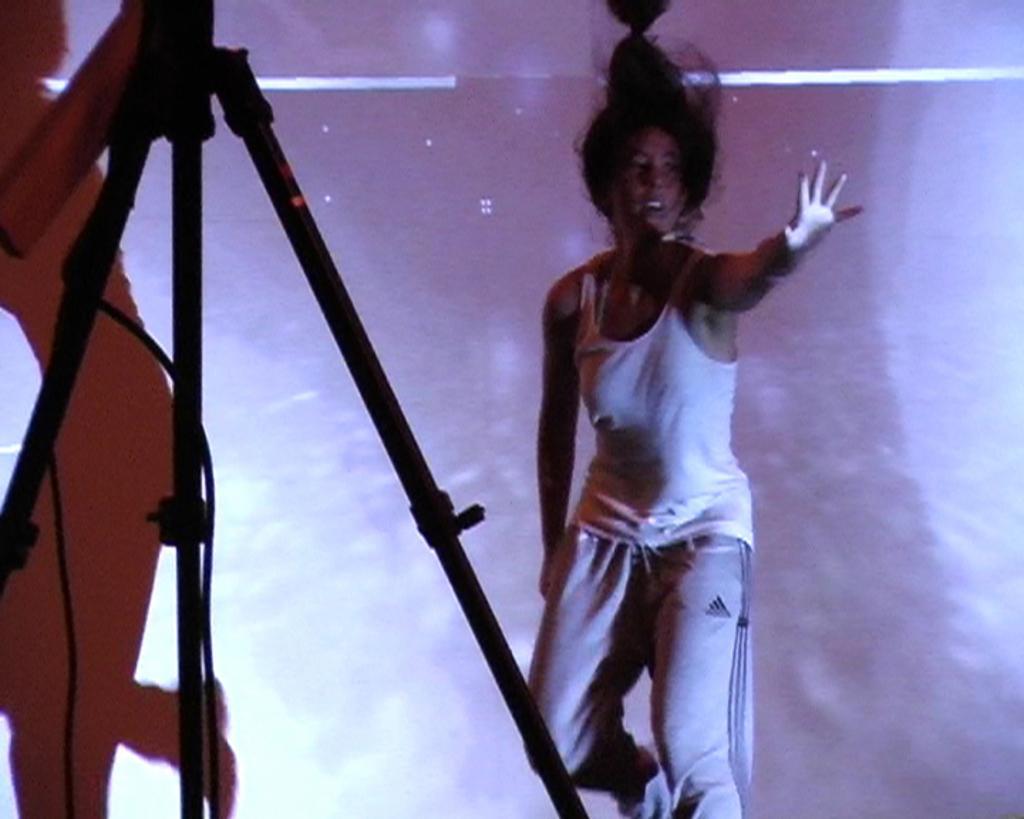Can you describe this image briefly? In this image I can see a woman wearing a white color t-shirt and in the background I can see pink color and on the left side I can see a stand and shadow of person. 